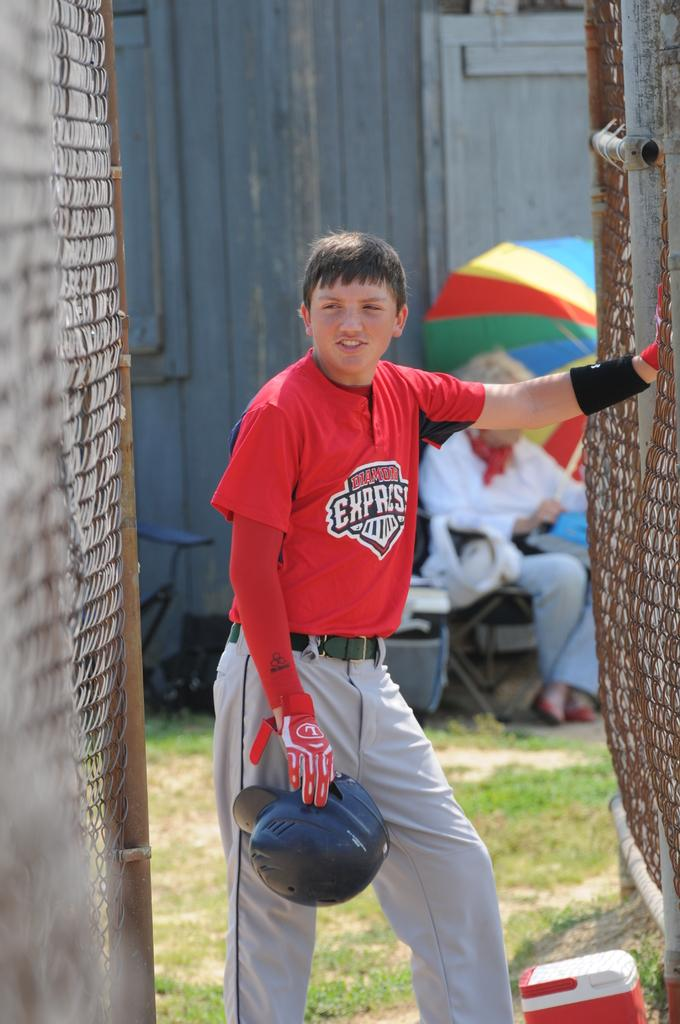<image>
Relay a brief, clear account of the picture shown. The boy is wearing red gloves with the letter L on the right glove. 